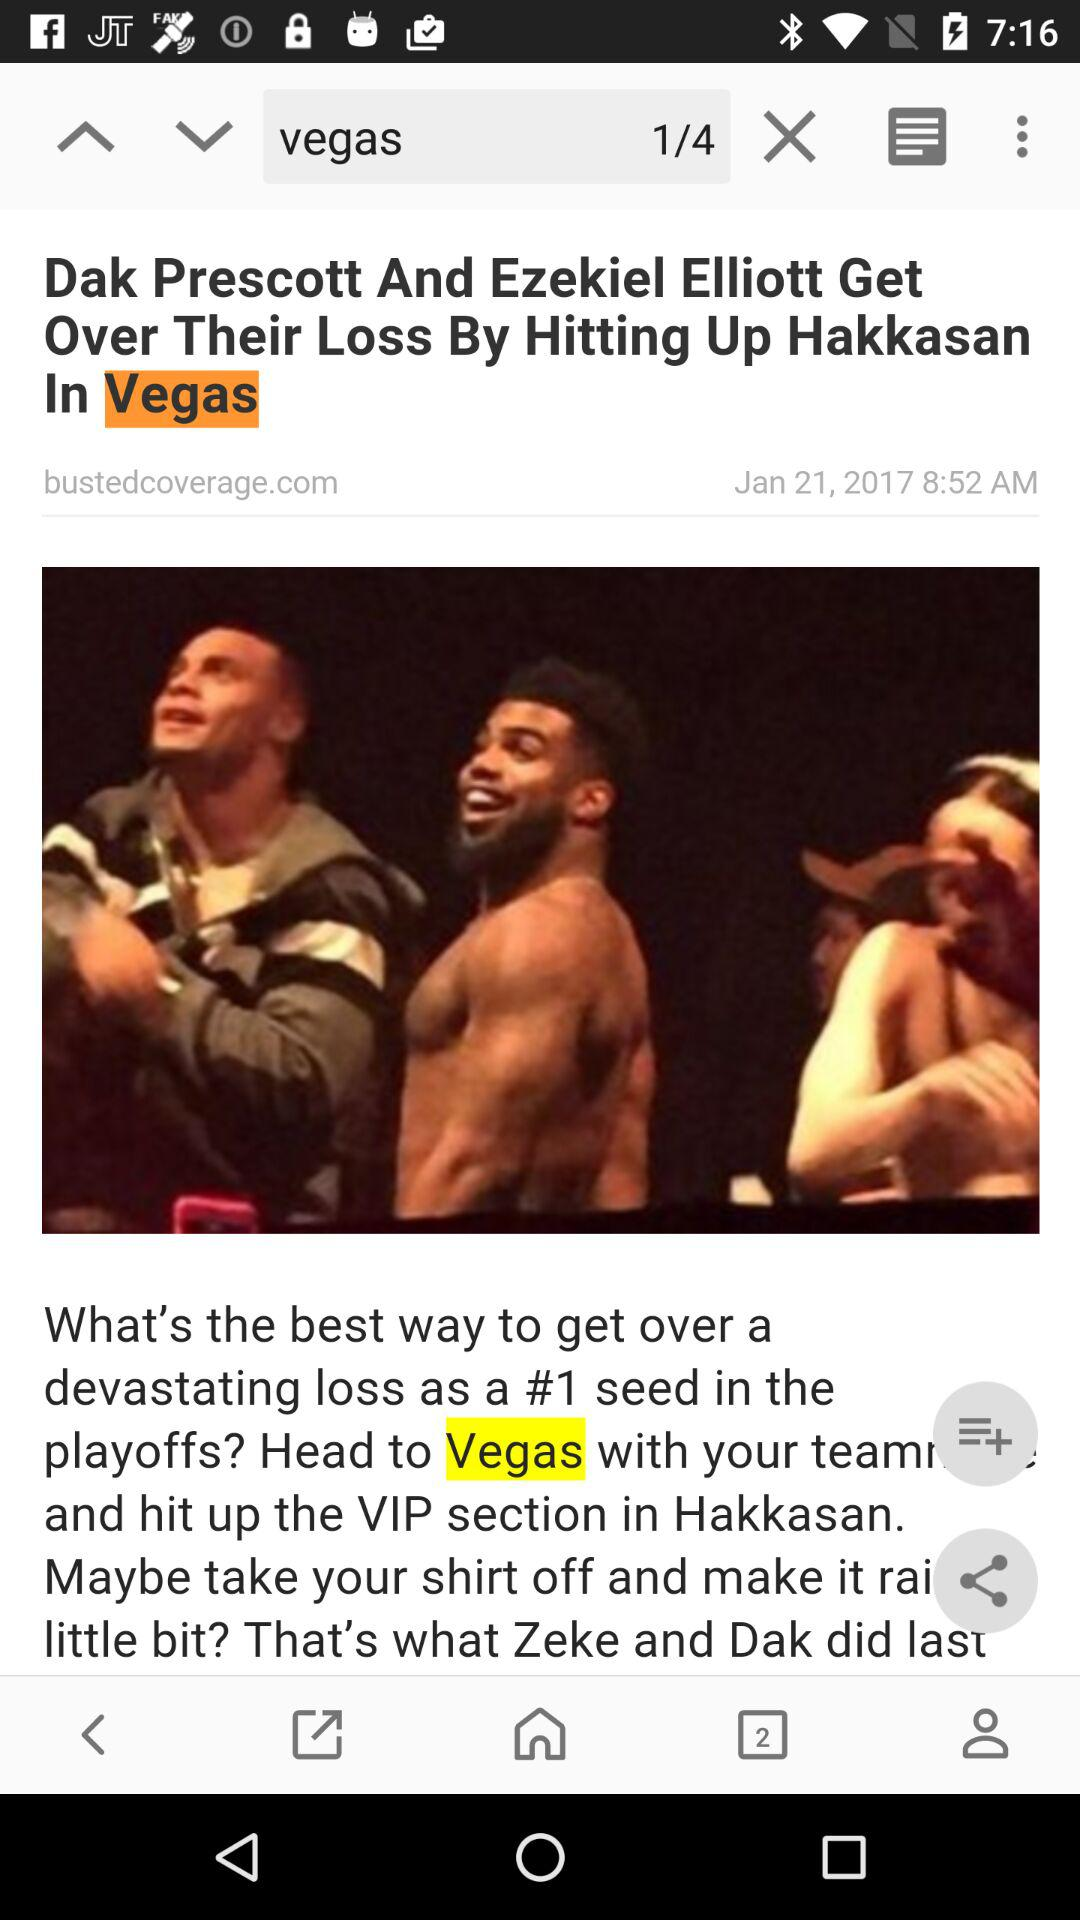What is the total number of searches for Vegas? The total number of searches for Vegas is 4. 